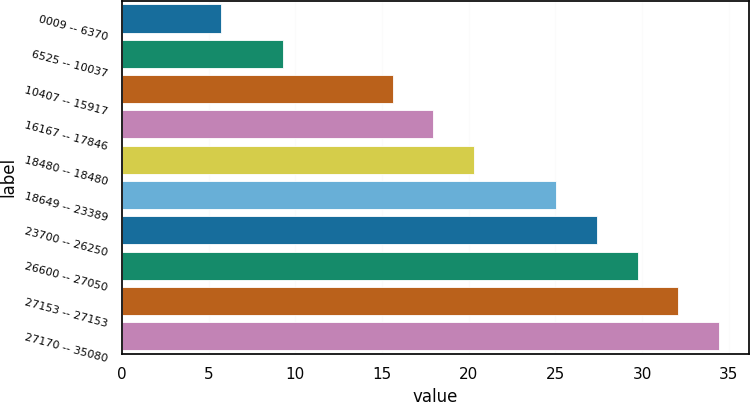Convert chart. <chart><loc_0><loc_0><loc_500><loc_500><bar_chart><fcel>0009 -- 6370<fcel>6525 -- 10037<fcel>10407 -- 15917<fcel>16167 -- 17846<fcel>18480 -- 18480<fcel>18649 -- 23389<fcel>23700 -- 26250<fcel>26600 -- 27050<fcel>27153 -- 27153<fcel>27170 -- 35080<nl><fcel>5.74<fcel>9.3<fcel>15.62<fcel>17.97<fcel>20.32<fcel>25.04<fcel>27.39<fcel>29.75<fcel>32.1<fcel>34.45<nl></chart> 